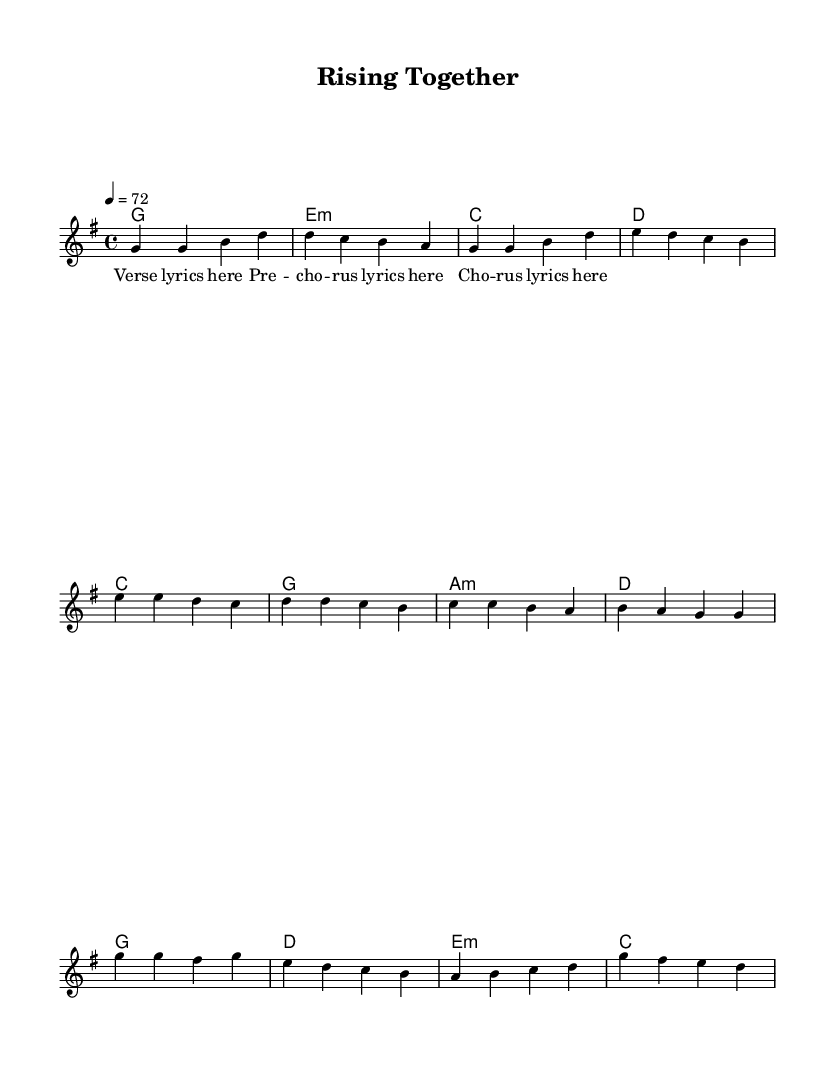What is the key signature of this music? The key signature is G major, which has one sharp (F#). This can be identified from the initial markings in the score.
Answer: G major What is the time signature of this piece? The time signature is 4/4, indicated at the beginning of the score. This means there are four beats in each measure and a quarter note gets one beat.
Answer: 4/4 What is the tempo marking of the piece? The tempo marking is 72 beats per minute, noted at the beginning of the score with "4 = 72", indicating the speed of the piece.
Answer: 72 How many sections are there in this composition? There are three main sections in the composition: Verse, Pre-Chorus, and Chorus, as indicated by the distinct markings in the lyric sections.
Answer: Three Which chord follows the first measure of the Verse? The chord following the first measure of the Verse is G major, identified by the chord symbols placed above the melody line in the score.
Answer: G What is the last chord of the Chorus? The last chord of the Chorus is C major, which can be seen clearly at the end of the chorus section in the chord progression.
Answer: C What thematic element does this ballad address based on its title? The title "Rising Together" suggests themes of community resilience and collaboration, as it implies a collective effort in facing challenges.
Answer: Community resilience 